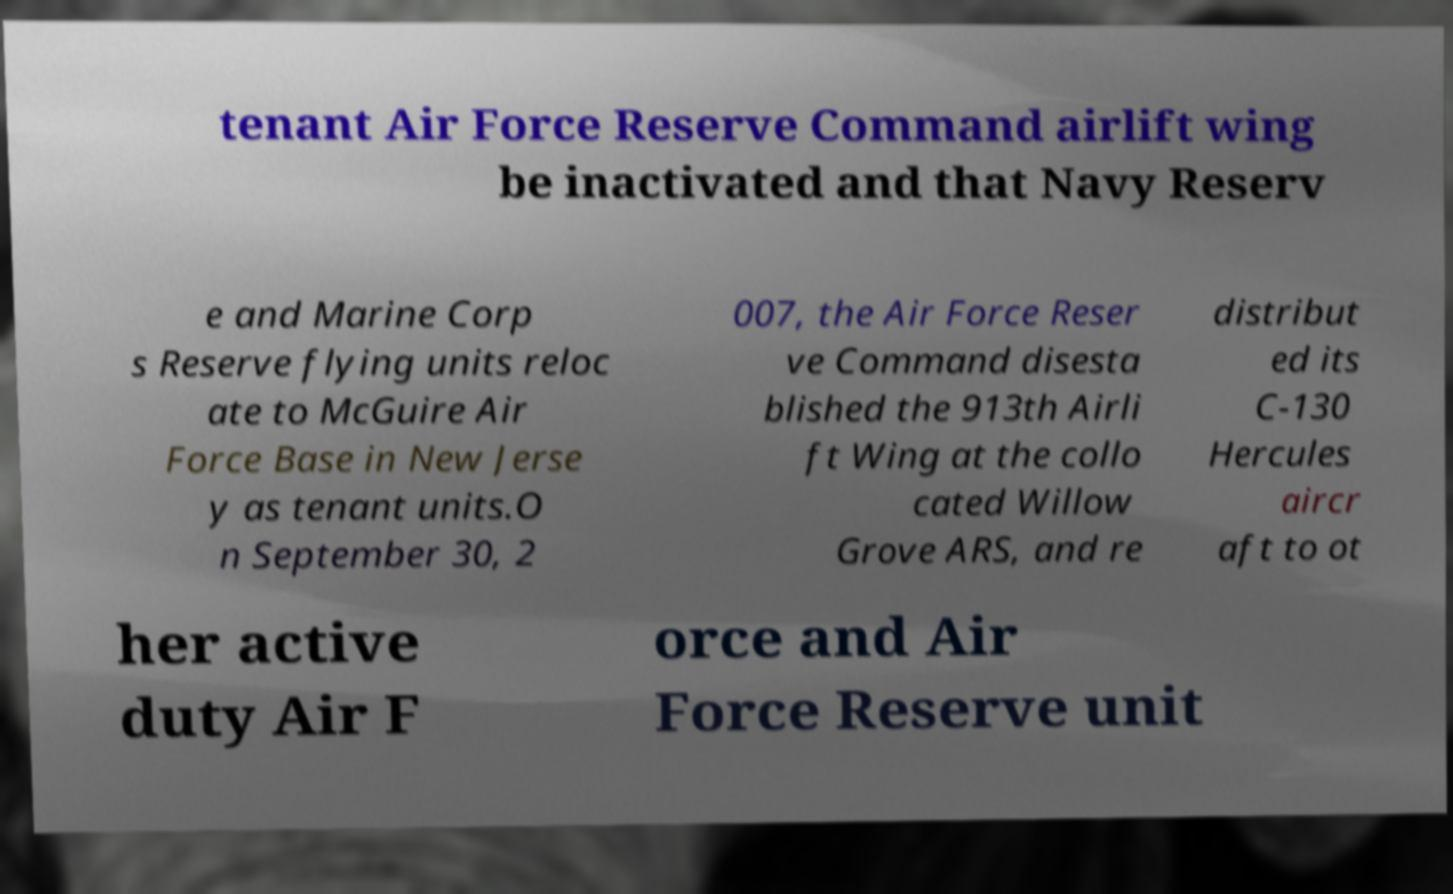What messages or text are displayed in this image? I need them in a readable, typed format. tenant Air Force Reserve Command airlift wing be inactivated and that Navy Reserv e and Marine Corp s Reserve flying units reloc ate to McGuire Air Force Base in New Jerse y as tenant units.O n September 30, 2 007, the Air Force Reser ve Command disesta blished the 913th Airli ft Wing at the collo cated Willow Grove ARS, and re distribut ed its C-130 Hercules aircr aft to ot her active duty Air F orce and Air Force Reserve unit 